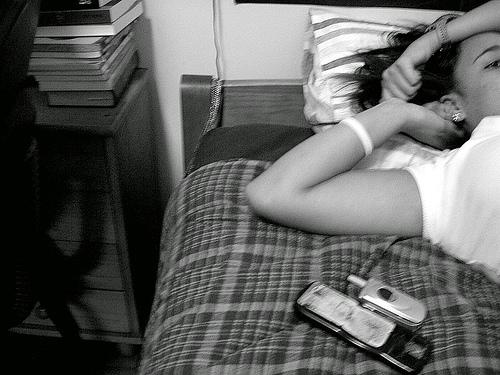Is the woman waiting for a call?
Concise answer only. Yes. Is she tech savvy?
Write a very short answer. Yes. Where is the woman laying?
Give a very brief answer. Bed. 